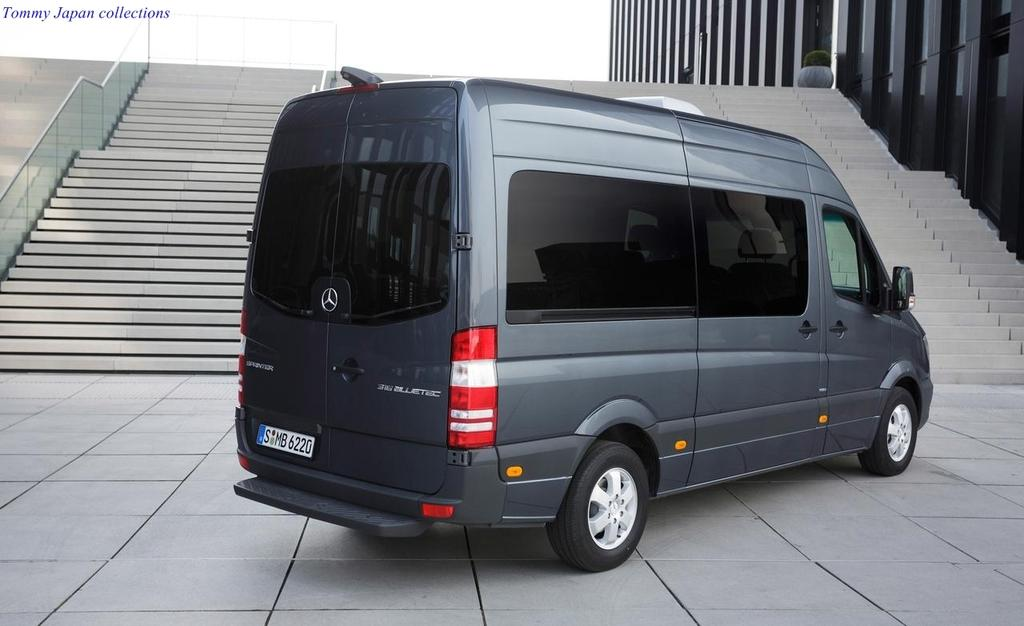<image>
Relay a brief, clear account of the picture shown. A GRAY WINDOWED VAN WITH LICENCE PLATE SMB6220 